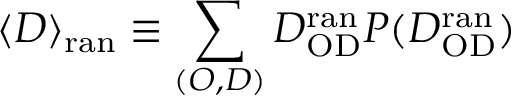Convert formula to latex. <formula><loc_0><loc_0><loc_500><loc_500>\langle D \rangle _ { r a n } \equiv \sum _ { ( O , D ) } D _ { O D } ^ { r a n } P ( D _ { O D } ^ { r a n } )</formula> 